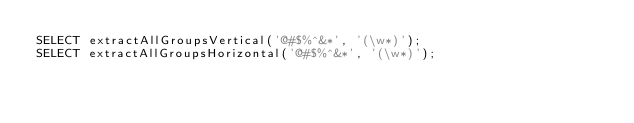<code> <loc_0><loc_0><loc_500><loc_500><_SQL_>SELECT extractAllGroupsVertical('@#$%^&*', '(\w*)');
SELECT extractAllGroupsHorizontal('@#$%^&*', '(\w*)');
</code> 